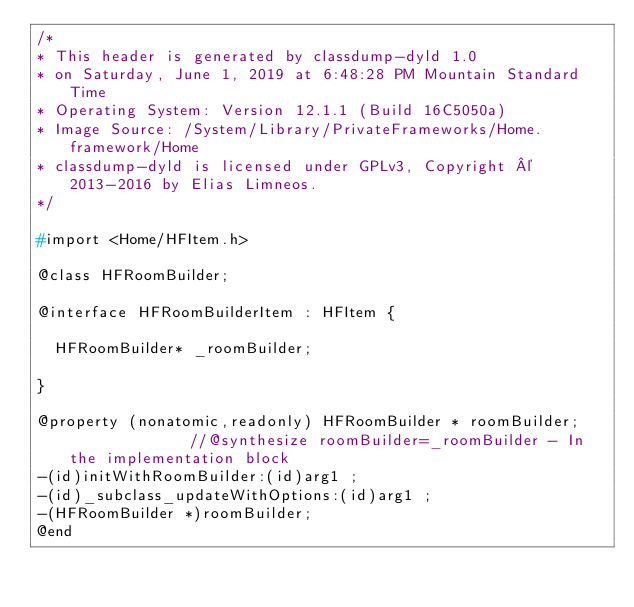<code> <loc_0><loc_0><loc_500><loc_500><_C_>/*
* This header is generated by classdump-dyld 1.0
* on Saturday, June 1, 2019 at 6:48:28 PM Mountain Standard Time
* Operating System: Version 12.1.1 (Build 16C5050a)
* Image Source: /System/Library/PrivateFrameworks/Home.framework/Home
* classdump-dyld is licensed under GPLv3, Copyright © 2013-2016 by Elias Limneos.
*/

#import <Home/HFItem.h>

@class HFRoomBuilder;

@interface HFRoomBuilderItem : HFItem {

	HFRoomBuilder* _roomBuilder;

}

@property (nonatomic,readonly) HFRoomBuilder * roomBuilder;              //@synthesize roomBuilder=_roomBuilder - In the implementation block
-(id)initWithRoomBuilder:(id)arg1 ;
-(id)_subclass_updateWithOptions:(id)arg1 ;
-(HFRoomBuilder *)roomBuilder;
@end

</code> 